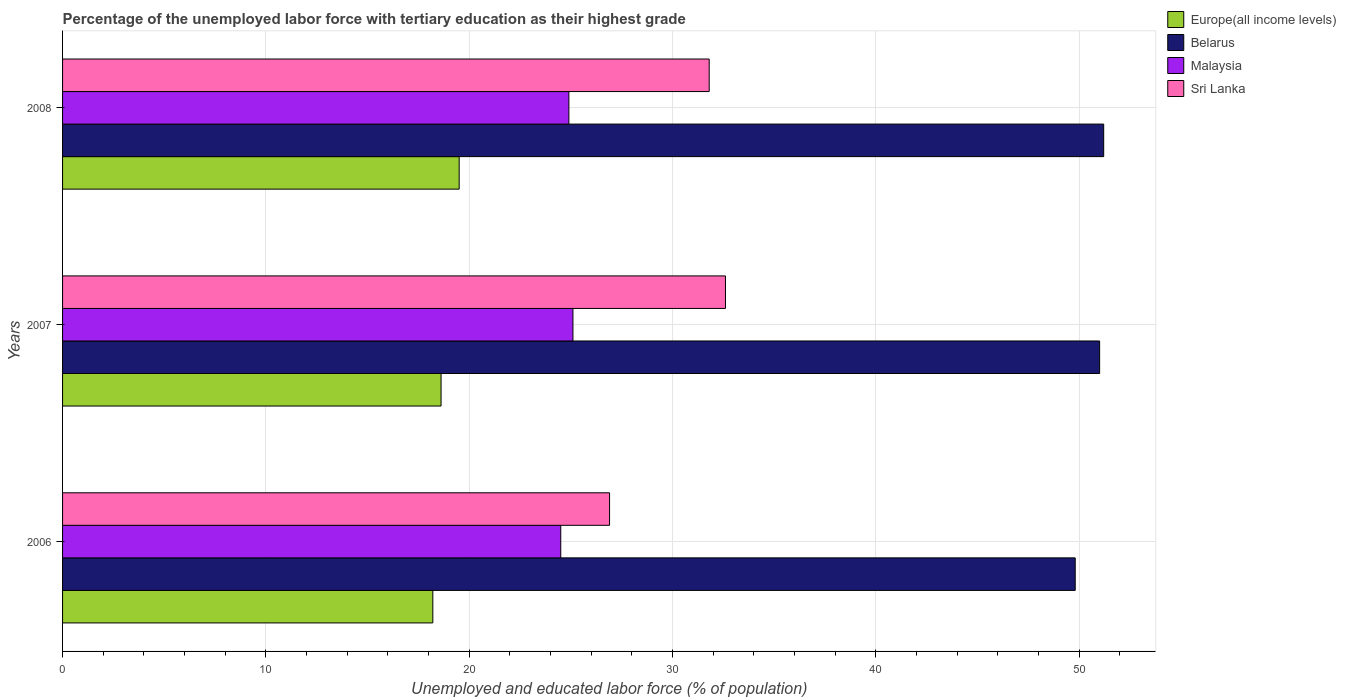How many different coloured bars are there?
Provide a short and direct response. 4. How many groups of bars are there?
Provide a succinct answer. 3. Are the number of bars per tick equal to the number of legend labels?
Provide a succinct answer. Yes. What is the label of the 3rd group of bars from the top?
Make the answer very short. 2006. What is the percentage of the unemployed labor force with tertiary education in Sri Lanka in 2007?
Offer a terse response. 32.6. Across all years, what is the maximum percentage of the unemployed labor force with tertiary education in Europe(all income levels)?
Provide a succinct answer. 19.5. Across all years, what is the minimum percentage of the unemployed labor force with tertiary education in Malaysia?
Give a very brief answer. 24.5. What is the total percentage of the unemployed labor force with tertiary education in Europe(all income levels) in the graph?
Ensure brevity in your answer.  56.33. What is the difference between the percentage of the unemployed labor force with tertiary education in Malaysia in 2006 and that in 2008?
Offer a terse response. -0.4. What is the difference between the percentage of the unemployed labor force with tertiary education in Sri Lanka in 2008 and the percentage of the unemployed labor force with tertiary education in Malaysia in 2007?
Make the answer very short. 6.7. What is the average percentage of the unemployed labor force with tertiary education in Malaysia per year?
Give a very brief answer. 24.83. In the year 2007, what is the difference between the percentage of the unemployed labor force with tertiary education in Belarus and percentage of the unemployed labor force with tertiary education in Malaysia?
Keep it short and to the point. 25.9. What is the ratio of the percentage of the unemployed labor force with tertiary education in Malaysia in 2006 to that in 2008?
Keep it short and to the point. 0.98. Is the difference between the percentage of the unemployed labor force with tertiary education in Belarus in 2006 and 2008 greater than the difference between the percentage of the unemployed labor force with tertiary education in Malaysia in 2006 and 2008?
Your answer should be compact. No. What is the difference between the highest and the second highest percentage of the unemployed labor force with tertiary education in Sri Lanka?
Make the answer very short. 0.8. What is the difference between the highest and the lowest percentage of the unemployed labor force with tertiary education in Sri Lanka?
Offer a terse response. 5.7. In how many years, is the percentage of the unemployed labor force with tertiary education in Belarus greater than the average percentage of the unemployed labor force with tertiary education in Belarus taken over all years?
Provide a succinct answer. 2. What does the 4th bar from the top in 2008 represents?
Make the answer very short. Europe(all income levels). What does the 4th bar from the bottom in 2007 represents?
Your answer should be very brief. Sri Lanka. Is it the case that in every year, the sum of the percentage of the unemployed labor force with tertiary education in Sri Lanka and percentage of the unemployed labor force with tertiary education in Malaysia is greater than the percentage of the unemployed labor force with tertiary education in Belarus?
Your answer should be very brief. Yes. How many bars are there?
Provide a succinct answer. 12. How many years are there in the graph?
Ensure brevity in your answer.  3. What is the difference between two consecutive major ticks on the X-axis?
Give a very brief answer. 10. Does the graph contain any zero values?
Provide a succinct answer. No. Does the graph contain grids?
Your response must be concise. Yes. How many legend labels are there?
Offer a terse response. 4. What is the title of the graph?
Provide a short and direct response. Percentage of the unemployed labor force with tertiary education as their highest grade. Does "Iran" appear as one of the legend labels in the graph?
Your answer should be compact. No. What is the label or title of the X-axis?
Offer a very short reply. Unemployed and educated labor force (% of population). What is the Unemployed and educated labor force (% of population) of Europe(all income levels) in 2006?
Your answer should be very brief. 18.21. What is the Unemployed and educated labor force (% of population) in Belarus in 2006?
Your answer should be very brief. 49.8. What is the Unemployed and educated labor force (% of population) in Malaysia in 2006?
Provide a short and direct response. 24.5. What is the Unemployed and educated labor force (% of population) in Sri Lanka in 2006?
Keep it short and to the point. 26.9. What is the Unemployed and educated labor force (% of population) in Europe(all income levels) in 2007?
Offer a very short reply. 18.61. What is the Unemployed and educated labor force (% of population) in Belarus in 2007?
Keep it short and to the point. 51. What is the Unemployed and educated labor force (% of population) in Malaysia in 2007?
Your answer should be compact. 25.1. What is the Unemployed and educated labor force (% of population) of Sri Lanka in 2007?
Your answer should be compact. 32.6. What is the Unemployed and educated labor force (% of population) of Europe(all income levels) in 2008?
Keep it short and to the point. 19.5. What is the Unemployed and educated labor force (% of population) of Belarus in 2008?
Give a very brief answer. 51.2. What is the Unemployed and educated labor force (% of population) of Malaysia in 2008?
Offer a terse response. 24.9. What is the Unemployed and educated labor force (% of population) in Sri Lanka in 2008?
Ensure brevity in your answer.  31.8. Across all years, what is the maximum Unemployed and educated labor force (% of population) in Europe(all income levels)?
Ensure brevity in your answer.  19.5. Across all years, what is the maximum Unemployed and educated labor force (% of population) in Belarus?
Keep it short and to the point. 51.2. Across all years, what is the maximum Unemployed and educated labor force (% of population) of Malaysia?
Your response must be concise. 25.1. Across all years, what is the maximum Unemployed and educated labor force (% of population) in Sri Lanka?
Make the answer very short. 32.6. Across all years, what is the minimum Unemployed and educated labor force (% of population) of Europe(all income levels)?
Make the answer very short. 18.21. Across all years, what is the minimum Unemployed and educated labor force (% of population) of Belarus?
Your response must be concise. 49.8. Across all years, what is the minimum Unemployed and educated labor force (% of population) in Sri Lanka?
Your answer should be compact. 26.9. What is the total Unemployed and educated labor force (% of population) of Europe(all income levels) in the graph?
Provide a short and direct response. 56.33. What is the total Unemployed and educated labor force (% of population) of Belarus in the graph?
Make the answer very short. 152. What is the total Unemployed and educated labor force (% of population) of Malaysia in the graph?
Offer a very short reply. 74.5. What is the total Unemployed and educated labor force (% of population) of Sri Lanka in the graph?
Ensure brevity in your answer.  91.3. What is the difference between the Unemployed and educated labor force (% of population) of Europe(all income levels) in 2006 and that in 2007?
Your answer should be compact. -0.41. What is the difference between the Unemployed and educated labor force (% of population) of Malaysia in 2006 and that in 2007?
Your answer should be compact. -0.6. What is the difference between the Unemployed and educated labor force (% of population) in Sri Lanka in 2006 and that in 2007?
Your response must be concise. -5.7. What is the difference between the Unemployed and educated labor force (% of population) in Europe(all income levels) in 2006 and that in 2008?
Offer a terse response. -1.3. What is the difference between the Unemployed and educated labor force (% of population) of Belarus in 2006 and that in 2008?
Provide a succinct answer. -1.4. What is the difference between the Unemployed and educated labor force (% of population) in Sri Lanka in 2006 and that in 2008?
Ensure brevity in your answer.  -4.9. What is the difference between the Unemployed and educated labor force (% of population) in Europe(all income levels) in 2007 and that in 2008?
Ensure brevity in your answer.  -0.89. What is the difference between the Unemployed and educated labor force (% of population) in Belarus in 2007 and that in 2008?
Give a very brief answer. -0.2. What is the difference between the Unemployed and educated labor force (% of population) in Europe(all income levels) in 2006 and the Unemployed and educated labor force (% of population) in Belarus in 2007?
Provide a succinct answer. -32.79. What is the difference between the Unemployed and educated labor force (% of population) in Europe(all income levels) in 2006 and the Unemployed and educated labor force (% of population) in Malaysia in 2007?
Keep it short and to the point. -6.89. What is the difference between the Unemployed and educated labor force (% of population) of Europe(all income levels) in 2006 and the Unemployed and educated labor force (% of population) of Sri Lanka in 2007?
Offer a very short reply. -14.39. What is the difference between the Unemployed and educated labor force (% of population) in Belarus in 2006 and the Unemployed and educated labor force (% of population) in Malaysia in 2007?
Your answer should be compact. 24.7. What is the difference between the Unemployed and educated labor force (% of population) in Europe(all income levels) in 2006 and the Unemployed and educated labor force (% of population) in Belarus in 2008?
Provide a short and direct response. -32.99. What is the difference between the Unemployed and educated labor force (% of population) of Europe(all income levels) in 2006 and the Unemployed and educated labor force (% of population) of Malaysia in 2008?
Provide a succinct answer. -6.69. What is the difference between the Unemployed and educated labor force (% of population) of Europe(all income levels) in 2006 and the Unemployed and educated labor force (% of population) of Sri Lanka in 2008?
Your answer should be compact. -13.59. What is the difference between the Unemployed and educated labor force (% of population) of Belarus in 2006 and the Unemployed and educated labor force (% of population) of Malaysia in 2008?
Keep it short and to the point. 24.9. What is the difference between the Unemployed and educated labor force (% of population) in Europe(all income levels) in 2007 and the Unemployed and educated labor force (% of population) in Belarus in 2008?
Your response must be concise. -32.59. What is the difference between the Unemployed and educated labor force (% of population) in Europe(all income levels) in 2007 and the Unemployed and educated labor force (% of population) in Malaysia in 2008?
Offer a terse response. -6.29. What is the difference between the Unemployed and educated labor force (% of population) of Europe(all income levels) in 2007 and the Unemployed and educated labor force (% of population) of Sri Lanka in 2008?
Offer a very short reply. -13.19. What is the difference between the Unemployed and educated labor force (% of population) of Belarus in 2007 and the Unemployed and educated labor force (% of population) of Malaysia in 2008?
Your response must be concise. 26.1. What is the difference between the Unemployed and educated labor force (% of population) in Malaysia in 2007 and the Unemployed and educated labor force (% of population) in Sri Lanka in 2008?
Your answer should be very brief. -6.7. What is the average Unemployed and educated labor force (% of population) of Europe(all income levels) per year?
Give a very brief answer. 18.78. What is the average Unemployed and educated labor force (% of population) of Belarus per year?
Your answer should be very brief. 50.67. What is the average Unemployed and educated labor force (% of population) of Malaysia per year?
Make the answer very short. 24.83. What is the average Unemployed and educated labor force (% of population) in Sri Lanka per year?
Provide a short and direct response. 30.43. In the year 2006, what is the difference between the Unemployed and educated labor force (% of population) in Europe(all income levels) and Unemployed and educated labor force (% of population) in Belarus?
Ensure brevity in your answer.  -31.59. In the year 2006, what is the difference between the Unemployed and educated labor force (% of population) of Europe(all income levels) and Unemployed and educated labor force (% of population) of Malaysia?
Offer a very short reply. -6.29. In the year 2006, what is the difference between the Unemployed and educated labor force (% of population) of Europe(all income levels) and Unemployed and educated labor force (% of population) of Sri Lanka?
Provide a succinct answer. -8.69. In the year 2006, what is the difference between the Unemployed and educated labor force (% of population) of Belarus and Unemployed and educated labor force (% of population) of Malaysia?
Provide a short and direct response. 25.3. In the year 2006, what is the difference between the Unemployed and educated labor force (% of population) of Belarus and Unemployed and educated labor force (% of population) of Sri Lanka?
Provide a short and direct response. 22.9. In the year 2006, what is the difference between the Unemployed and educated labor force (% of population) in Malaysia and Unemployed and educated labor force (% of population) in Sri Lanka?
Ensure brevity in your answer.  -2.4. In the year 2007, what is the difference between the Unemployed and educated labor force (% of population) of Europe(all income levels) and Unemployed and educated labor force (% of population) of Belarus?
Provide a short and direct response. -32.39. In the year 2007, what is the difference between the Unemployed and educated labor force (% of population) of Europe(all income levels) and Unemployed and educated labor force (% of population) of Malaysia?
Your answer should be compact. -6.49. In the year 2007, what is the difference between the Unemployed and educated labor force (% of population) in Europe(all income levels) and Unemployed and educated labor force (% of population) in Sri Lanka?
Provide a succinct answer. -13.99. In the year 2007, what is the difference between the Unemployed and educated labor force (% of population) of Belarus and Unemployed and educated labor force (% of population) of Malaysia?
Provide a succinct answer. 25.9. In the year 2008, what is the difference between the Unemployed and educated labor force (% of population) in Europe(all income levels) and Unemployed and educated labor force (% of population) in Belarus?
Offer a terse response. -31.7. In the year 2008, what is the difference between the Unemployed and educated labor force (% of population) in Europe(all income levels) and Unemployed and educated labor force (% of population) in Malaysia?
Provide a short and direct response. -5.4. In the year 2008, what is the difference between the Unemployed and educated labor force (% of population) in Europe(all income levels) and Unemployed and educated labor force (% of population) in Sri Lanka?
Your response must be concise. -12.3. In the year 2008, what is the difference between the Unemployed and educated labor force (% of population) of Belarus and Unemployed and educated labor force (% of population) of Malaysia?
Offer a very short reply. 26.3. What is the ratio of the Unemployed and educated labor force (% of population) in Europe(all income levels) in 2006 to that in 2007?
Give a very brief answer. 0.98. What is the ratio of the Unemployed and educated labor force (% of population) of Belarus in 2006 to that in 2007?
Your answer should be compact. 0.98. What is the ratio of the Unemployed and educated labor force (% of population) of Malaysia in 2006 to that in 2007?
Provide a short and direct response. 0.98. What is the ratio of the Unemployed and educated labor force (% of population) in Sri Lanka in 2006 to that in 2007?
Keep it short and to the point. 0.83. What is the ratio of the Unemployed and educated labor force (% of population) of Europe(all income levels) in 2006 to that in 2008?
Your response must be concise. 0.93. What is the ratio of the Unemployed and educated labor force (% of population) of Belarus in 2006 to that in 2008?
Provide a succinct answer. 0.97. What is the ratio of the Unemployed and educated labor force (% of population) in Malaysia in 2006 to that in 2008?
Your answer should be very brief. 0.98. What is the ratio of the Unemployed and educated labor force (% of population) in Sri Lanka in 2006 to that in 2008?
Ensure brevity in your answer.  0.85. What is the ratio of the Unemployed and educated labor force (% of population) in Europe(all income levels) in 2007 to that in 2008?
Ensure brevity in your answer.  0.95. What is the ratio of the Unemployed and educated labor force (% of population) of Malaysia in 2007 to that in 2008?
Your response must be concise. 1.01. What is the ratio of the Unemployed and educated labor force (% of population) in Sri Lanka in 2007 to that in 2008?
Offer a very short reply. 1.03. What is the difference between the highest and the second highest Unemployed and educated labor force (% of population) of Europe(all income levels)?
Keep it short and to the point. 0.89. What is the difference between the highest and the second highest Unemployed and educated labor force (% of population) of Belarus?
Your answer should be compact. 0.2. What is the difference between the highest and the second highest Unemployed and educated labor force (% of population) of Malaysia?
Offer a very short reply. 0.2. What is the difference between the highest and the lowest Unemployed and educated labor force (% of population) in Europe(all income levels)?
Your response must be concise. 1.3. What is the difference between the highest and the lowest Unemployed and educated labor force (% of population) of Belarus?
Give a very brief answer. 1.4. What is the difference between the highest and the lowest Unemployed and educated labor force (% of population) of Malaysia?
Make the answer very short. 0.6. 